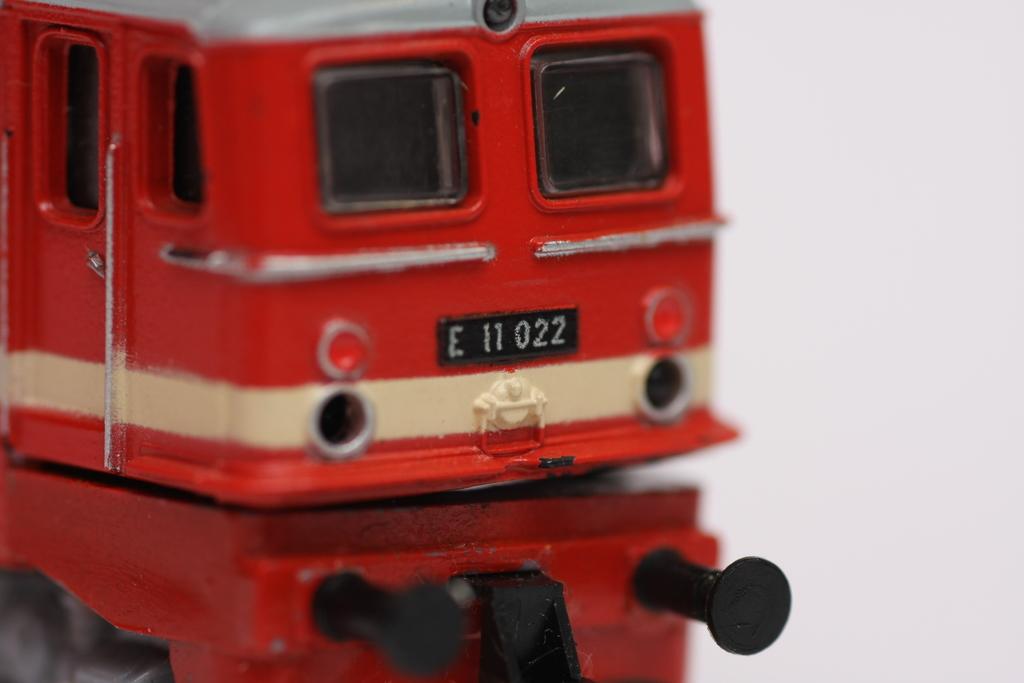What is the licences plate of the truck?
Provide a short and direct response. E 11 022. 